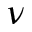Convert formula to latex. <formula><loc_0><loc_0><loc_500><loc_500>\nu</formula> 